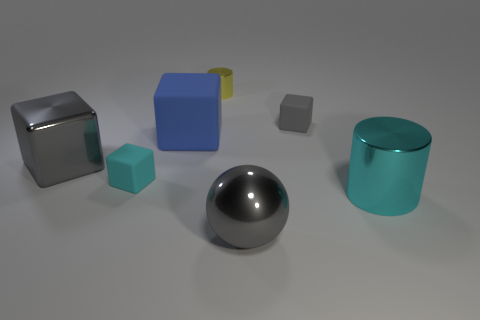What number of things are either metallic cylinders behind the large cyan metal cylinder or rubber objects that are to the left of the sphere?
Your answer should be compact. 3. Do the cyan metallic cylinder and the gray matte cube behind the large gray metal ball have the same size?
Give a very brief answer. No. Is the material of the small block that is left of the yellow shiny cylinder the same as the small cube that is to the right of the small yellow metal object?
Your answer should be compact. Yes. Is the number of big balls behind the tiny cyan rubber object the same as the number of gray metal cubes that are behind the big sphere?
Ensure brevity in your answer.  No. What number of big rubber objects are the same color as the metallic sphere?
Keep it short and to the point. 0. There is a small object that is the same color as the ball; what is it made of?
Your answer should be very brief. Rubber. How many shiny objects are either gray things or tiny gray blocks?
Offer a terse response. 2. Is the shape of the metal object that is behind the big matte cube the same as the small matte thing on the left side of the tiny metal cylinder?
Make the answer very short. No. What number of big gray metallic things are to the left of the big gray metallic block?
Make the answer very short. 0. Is there a big cyan thing that has the same material as the gray ball?
Offer a terse response. Yes. 